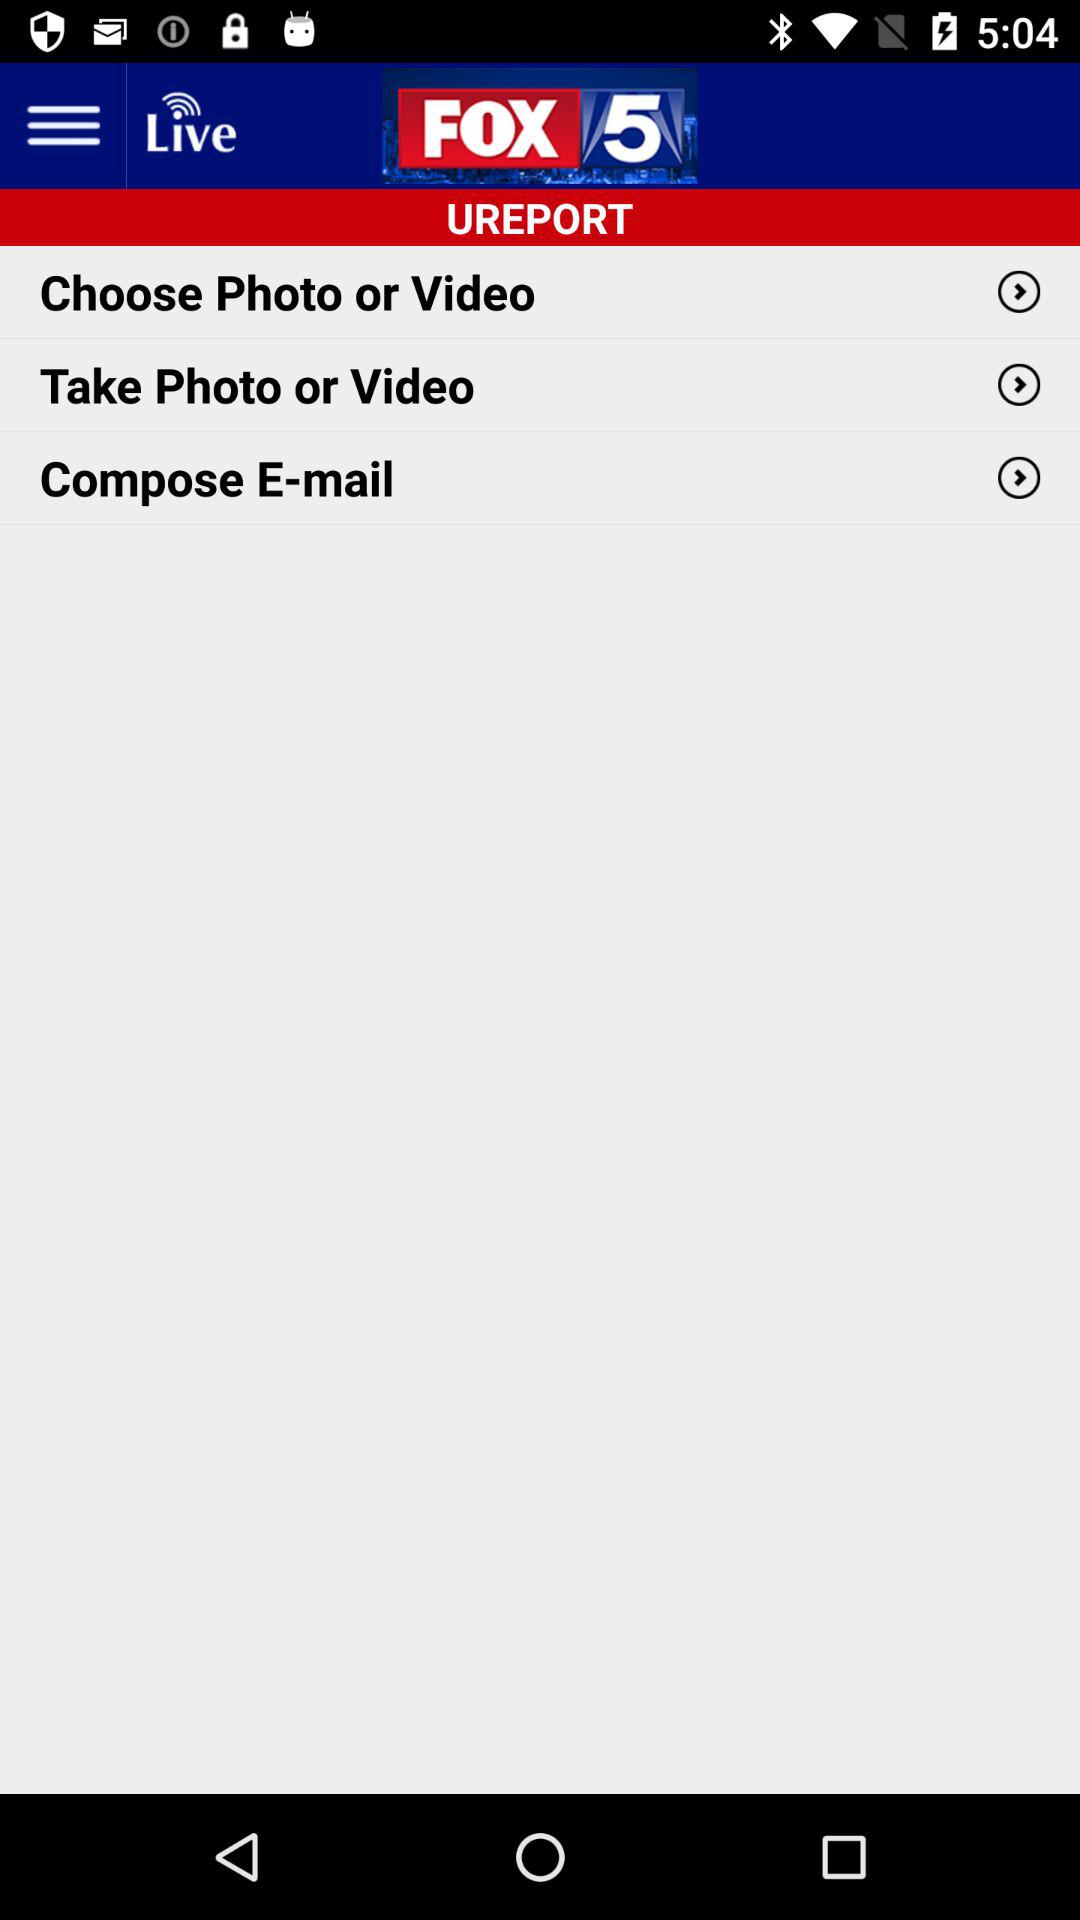Which photos have been chosen?
When the provided information is insufficient, respond with <no answer>. <no answer> 